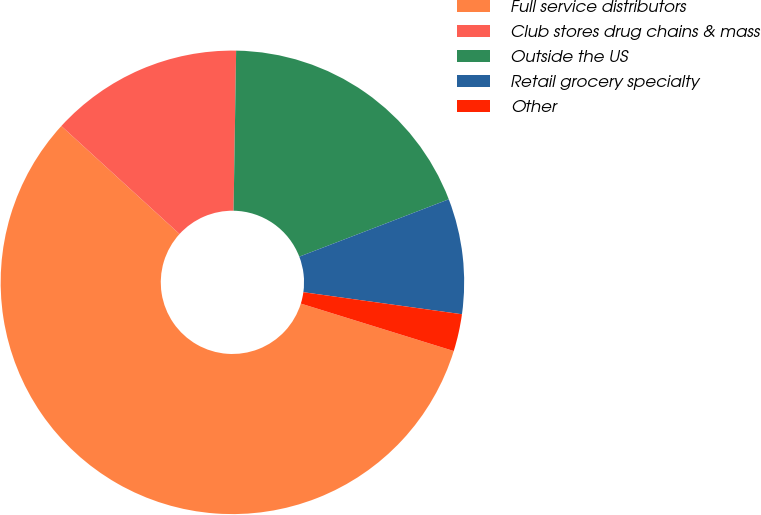Convert chart. <chart><loc_0><loc_0><loc_500><loc_500><pie_chart><fcel>Full service distributors<fcel>Club stores drug chains & mass<fcel>Outside the US<fcel>Retail grocery specialty<fcel>Other<nl><fcel>56.99%<fcel>13.47%<fcel>18.91%<fcel>8.03%<fcel>2.59%<nl></chart> 